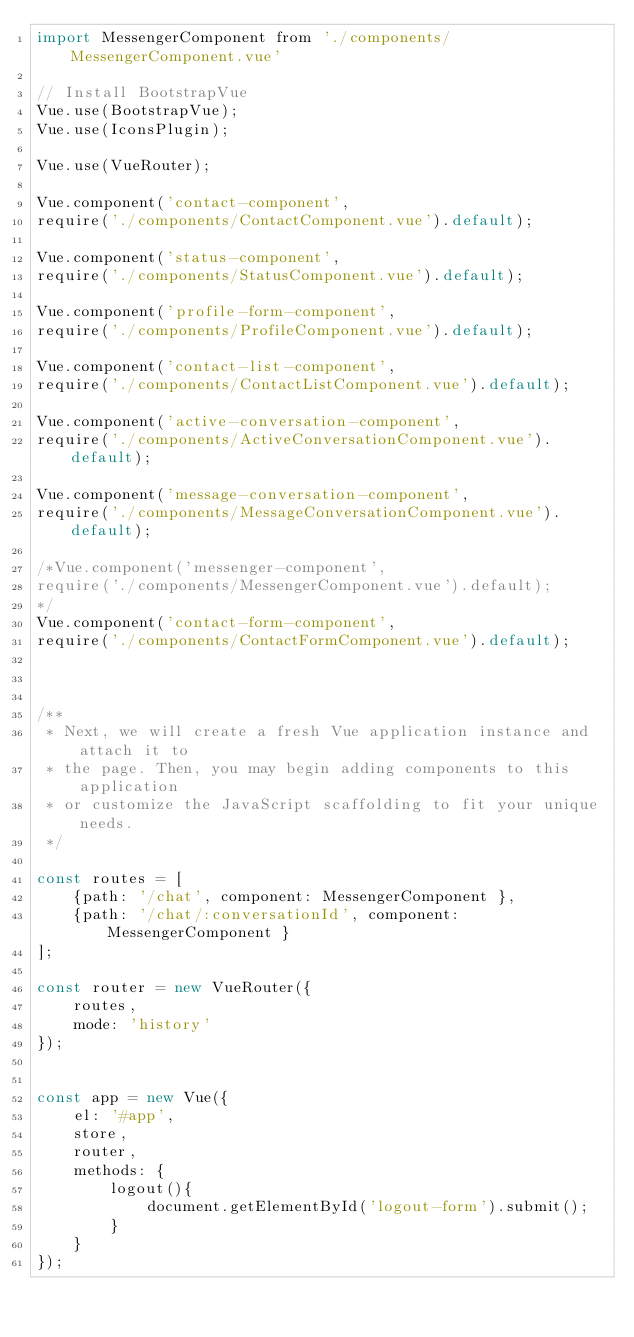<code> <loc_0><loc_0><loc_500><loc_500><_JavaScript_>import MessengerComponent from './components/MessengerComponent.vue'

// Install BootstrapVue
Vue.use(BootstrapVue);
Vue.use(IconsPlugin);

Vue.use(VueRouter);

Vue.component('contact-component', 
require('./components/ContactComponent.vue').default);

Vue.component('status-component', 
require('./components/StatusComponent.vue').default);

Vue.component('profile-form-component', 
require('./components/ProfileComponent.vue').default);

Vue.component('contact-list-component', 
require('./components/ContactListComponent.vue').default);

Vue.component('active-conversation-component', 
require('./components/ActiveConversationComponent.vue').default);

Vue.component('message-conversation-component', 
require('./components/MessageConversationComponent.vue').default);

/*Vue.component('messenger-component', 
require('./components/MessengerComponent.vue').default);
*/
Vue.component('contact-form-component', 
require('./components/ContactFormComponent.vue').default);



/**
 * Next, we will create a fresh Vue application instance and attach it to
 * the page. Then, you may begin adding components to this application
 * or customize the JavaScript scaffolding to fit your unique needs.
 */

const routes = [
    {path: '/chat', component: MessengerComponent },
    {path: '/chat/:conversationId', component: MessengerComponent }
];

const router = new VueRouter({
    routes,
    mode: 'history'
});


const app = new Vue({
    el: '#app',
    store,
    router,
    methods: {
        logout(){
            document.getElementById('logout-form').submit();
        }
    }
});
</code> 